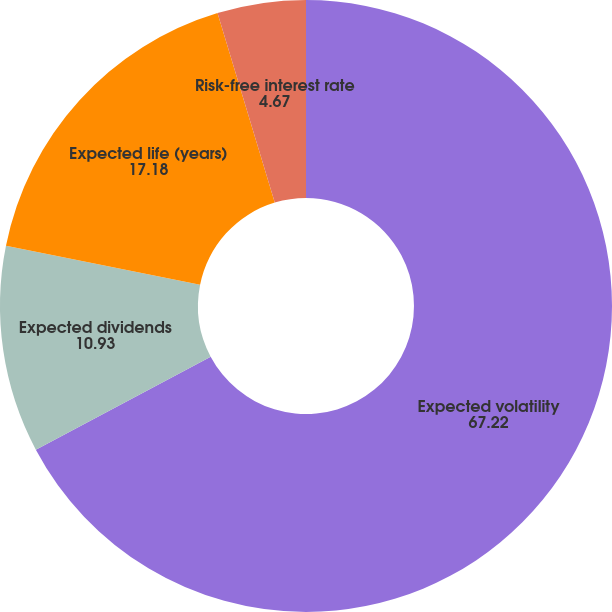Convert chart. <chart><loc_0><loc_0><loc_500><loc_500><pie_chart><fcel>Expected volatility<fcel>Expected dividends<fcel>Expected life (years)<fcel>Risk-free interest rate<nl><fcel>67.22%<fcel>10.93%<fcel>17.18%<fcel>4.67%<nl></chart> 